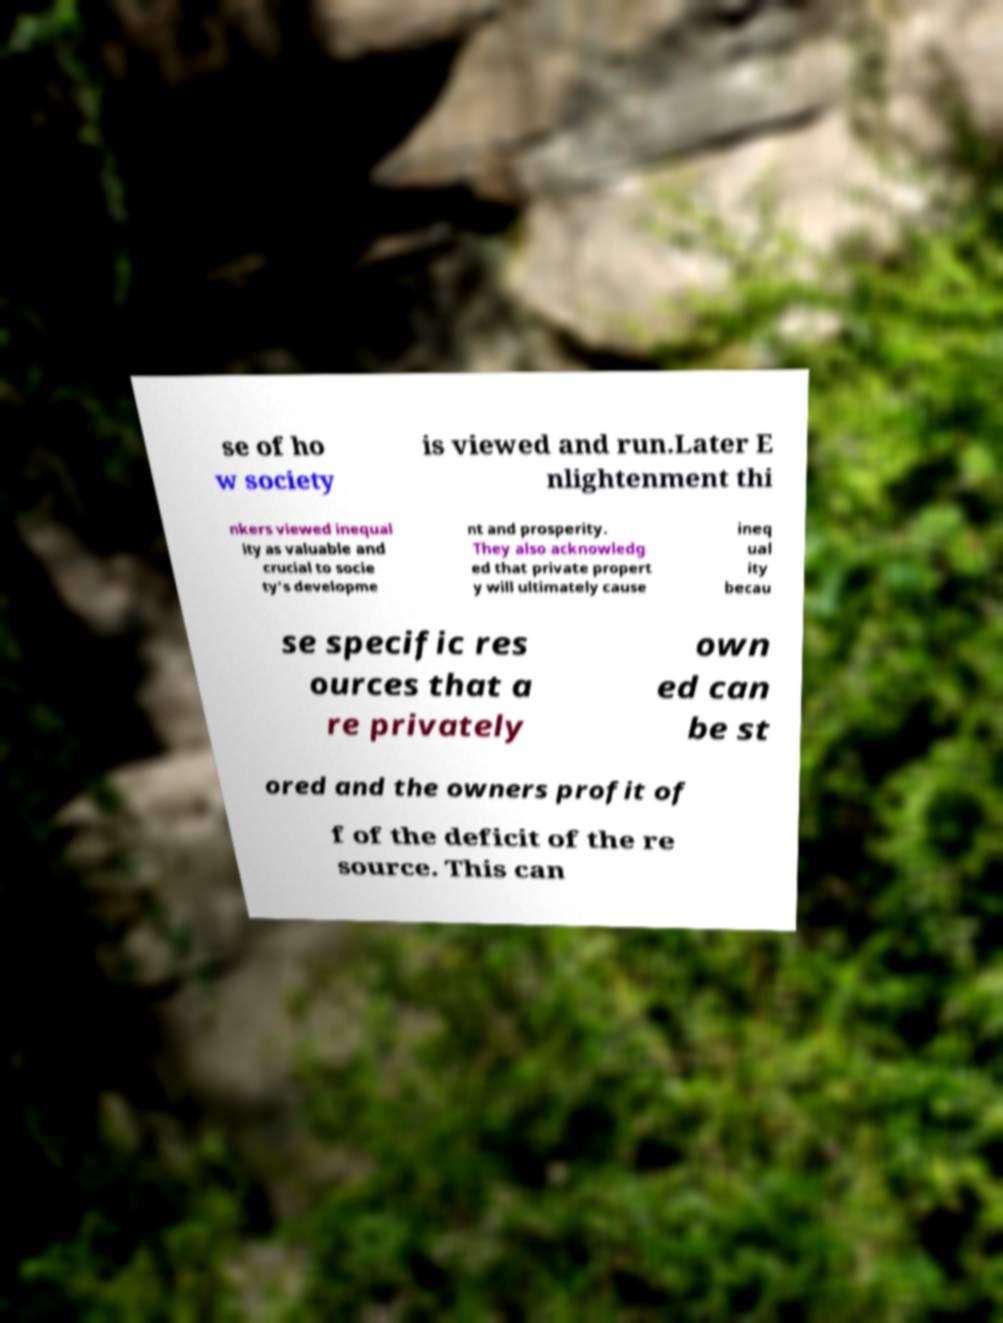Please identify and transcribe the text found in this image. se of ho w society is viewed and run.Later E nlightenment thi nkers viewed inequal ity as valuable and crucial to socie ty's developme nt and prosperity. They also acknowledg ed that private propert y will ultimately cause ineq ual ity becau se specific res ources that a re privately own ed can be st ored and the owners profit of f of the deficit of the re source. This can 